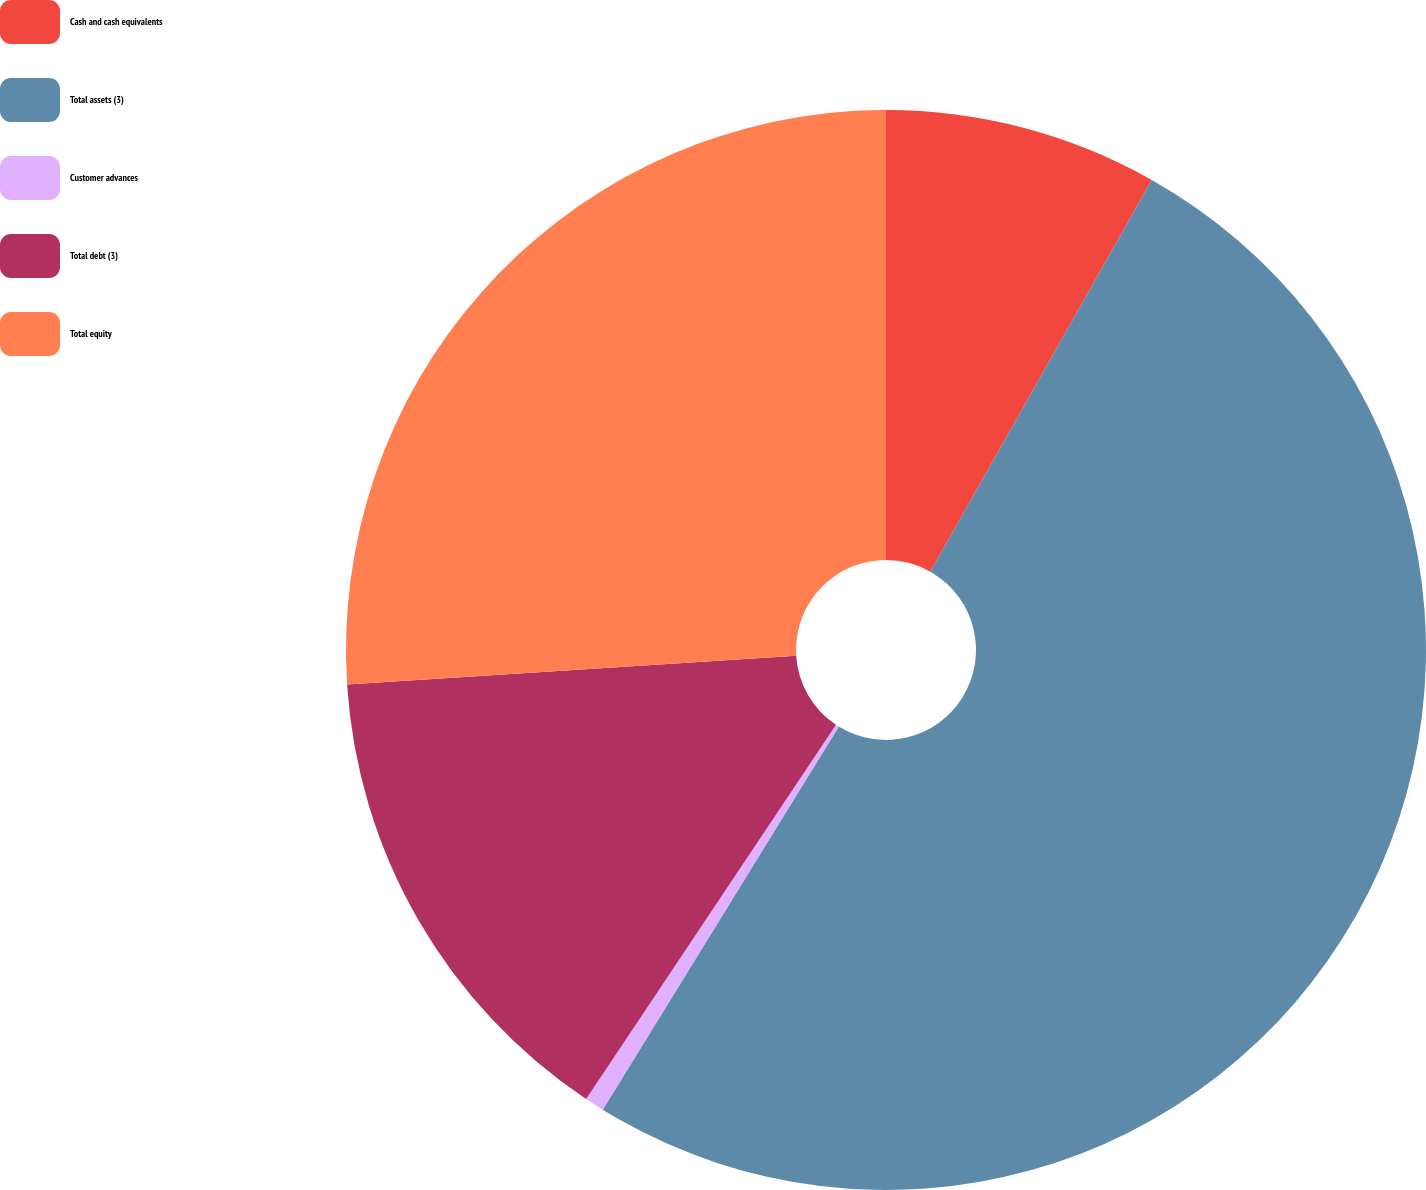Convert chart. <chart><loc_0><loc_0><loc_500><loc_500><pie_chart><fcel>Cash and cash equivalents<fcel>Total assets (3)<fcel>Customer advances<fcel>Total debt (3)<fcel>Total equity<nl><fcel>8.19%<fcel>50.6%<fcel>0.58%<fcel>14.61%<fcel>26.02%<nl></chart> 